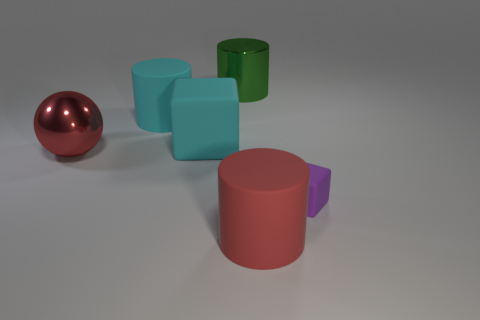Add 2 small green spheres. How many objects exist? 8 Subtract all balls. How many objects are left? 5 Add 2 tiny matte blocks. How many tiny matte blocks exist? 3 Subtract 1 cyan cubes. How many objects are left? 5 Subtract all large blue rubber cylinders. Subtract all shiny cylinders. How many objects are left? 5 Add 5 large red matte cylinders. How many large red matte cylinders are left? 6 